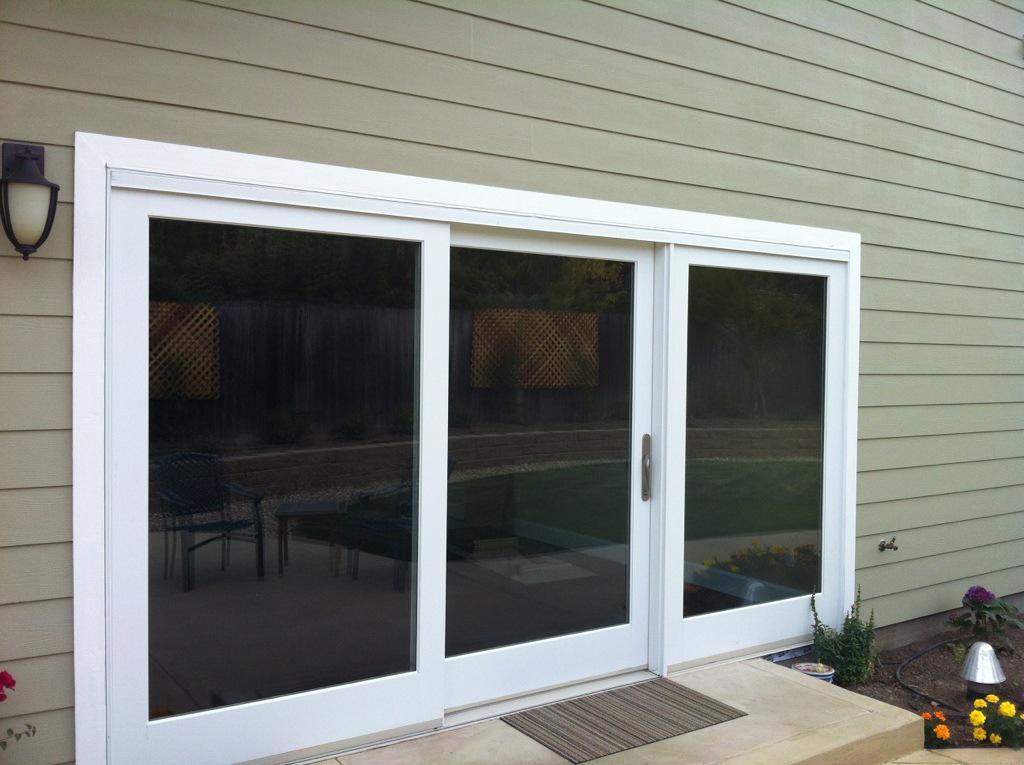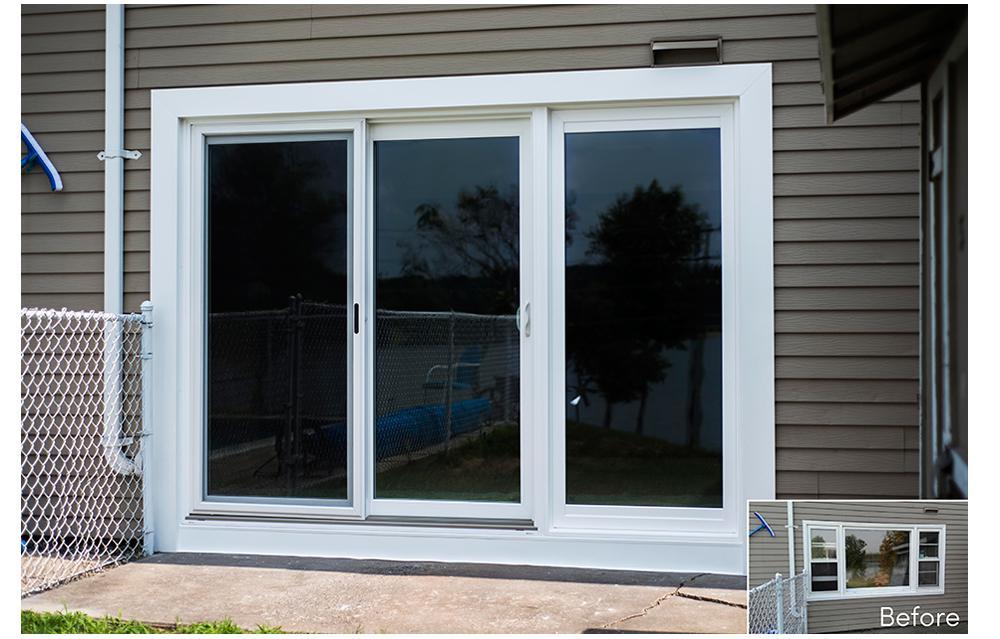The first image is the image on the left, the second image is the image on the right. Examine the images to the left and right. Is the description "Right image shows a sliding door unit with four door-shaped sections that don't have paned glass." accurate? Answer yes or no. No. The first image is the image on the left, the second image is the image on the right. For the images shown, is this caption "A floor mat sits outside one of the doors." true? Answer yes or no. Yes. 